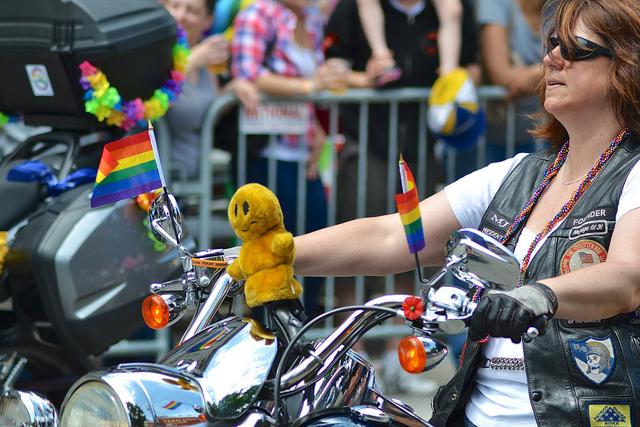What are they riding?
Concise answer only. Motorcycle. Is the woman wearing a jacket?
Give a very brief answer. No. Are there any flags on the motorbike?
Concise answer only. Yes. What is on the front of the motorcycle?
Answer briefly. Stuffed animal. 